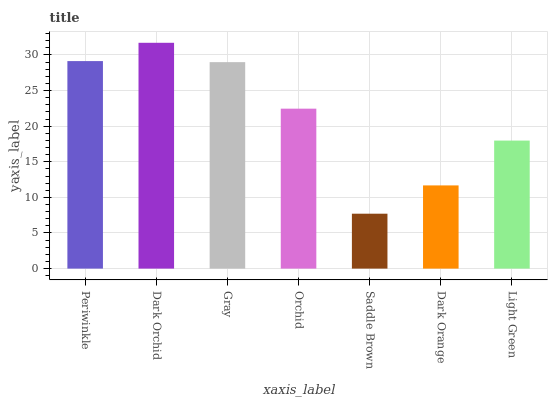Is Saddle Brown the minimum?
Answer yes or no. Yes. Is Dark Orchid the maximum?
Answer yes or no. Yes. Is Gray the minimum?
Answer yes or no. No. Is Gray the maximum?
Answer yes or no. No. Is Dark Orchid greater than Gray?
Answer yes or no. Yes. Is Gray less than Dark Orchid?
Answer yes or no. Yes. Is Gray greater than Dark Orchid?
Answer yes or no. No. Is Dark Orchid less than Gray?
Answer yes or no. No. Is Orchid the high median?
Answer yes or no. Yes. Is Orchid the low median?
Answer yes or no. Yes. Is Dark Orange the high median?
Answer yes or no. No. Is Light Green the low median?
Answer yes or no. No. 